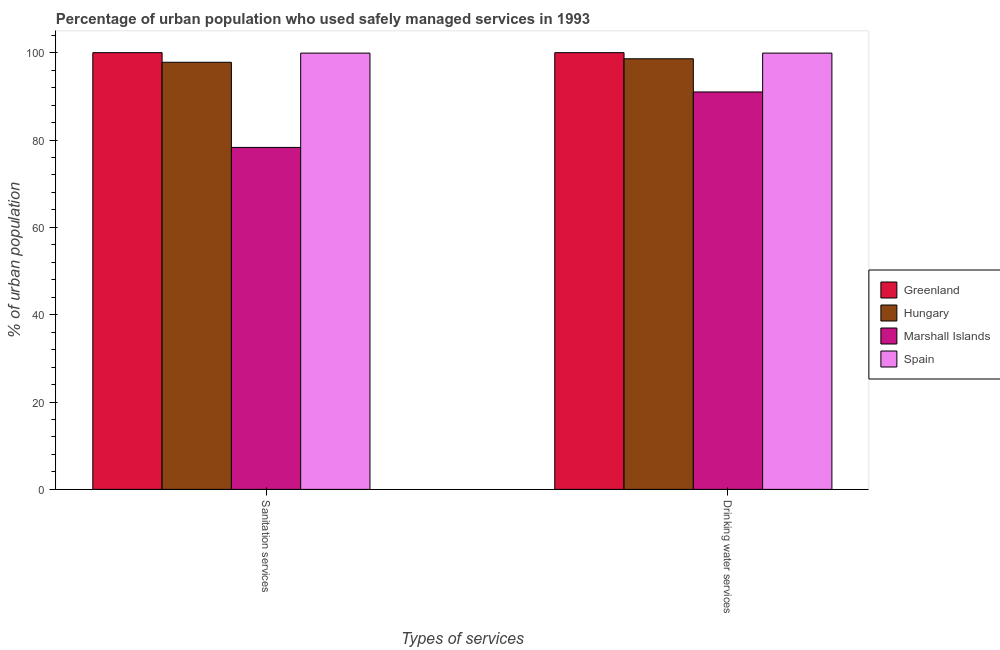How many different coloured bars are there?
Your response must be concise. 4. How many bars are there on the 1st tick from the left?
Your answer should be compact. 4. How many bars are there on the 2nd tick from the right?
Make the answer very short. 4. What is the label of the 1st group of bars from the left?
Keep it short and to the point. Sanitation services. What is the percentage of urban population who used drinking water services in Marshall Islands?
Your response must be concise. 91. Across all countries, what is the maximum percentage of urban population who used drinking water services?
Keep it short and to the point. 100. Across all countries, what is the minimum percentage of urban population who used sanitation services?
Keep it short and to the point. 78.3. In which country was the percentage of urban population who used sanitation services maximum?
Make the answer very short. Greenland. In which country was the percentage of urban population who used sanitation services minimum?
Offer a terse response. Marshall Islands. What is the total percentage of urban population who used sanitation services in the graph?
Your answer should be compact. 376. What is the difference between the percentage of urban population who used drinking water services in Hungary and that in Marshall Islands?
Make the answer very short. 7.6. What is the difference between the percentage of urban population who used drinking water services in Spain and the percentage of urban population who used sanitation services in Greenland?
Ensure brevity in your answer.  -0.1. What is the average percentage of urban population who used sanitation services per country?
Give a very brief answer. 94. What is the ratio of the percentage of urban population who used drinking water services in Marshall Islands to that in Spain?
Your response must be concise. 0.91. Is the percentage of urban population who used sanitation services in Hungary less than that in Spain?
Offer a terse response. Yes. In how many countries, is the percentage of urban population who used drinking water services greater than the average percentage of urban population who used drinking water services taken over all countries?
Keep it short and to the point. 3. What does the 3rd bar from the left in Drinking water services represents?
Offer a terse response. Marshall Islands. Are all the bars in the graph horizontal?
Keep it short and to the point. No. What is the difference between two consecutive major ticks on the Y-axis?
Make the answer very short. 20. Where does the legend appear in the graph?
Make the answer very short. Center right. How many legend labels are there?
Your answer should be compact. 4. What is the title of the graph?
Your answer should be compact. Percentage of urban population who used safely managed services in 1993. What is the label or title of the X-axis?
Provide a succinct answer. Types of services. What is the label or title of the Y-axis?
Your answer should be very brief. % of urban population. What is the % of urban population in Greenland in Sanitation services?
Keep it short and to the point. 100. What is the % of urban population in Hungary in Sanitation services?
Make the answer very short. 97.8. What is the % of urban population of Marshall Islands in Sanitation services?
Offer a very short reply. 78.3. What is the % of urban population of Spain in Sanitation services?
Provide a short and direct response. 99.9. What is the % of urban population of Greenland in Drinking water services?
Make the answer very short. 100. What is the % of urban population of Hungary in Drinking water services?
Offer a terse response. 98.6. What is the % of urban population of Marshall Islands in Drinking water services?
Your response must be concise. 91. What is the % of urban population of Spain in Drinking water services?
Offer a terse response. 99.9. Across all Types of services, what is the maximum % of urban population of Hungary?
Offer a very short reply. 98.6. Across all Types of services, what is the maximum % of urban population in Marshall Islands?
Your response must be concise. 91. Across all Types of services, what is the maximum % of urban population in Spain?
Your response must be concise. 99.9. Across all Types of services, what is the minimum % of urban population of Greenland?
Provide a short and direct response. 100. Across all Types of services, what is the minimum % of urban population in Hungary?
Provide a short and direct response. 97.8. Across all Types of services, what is the minimum % of urban population of Marshall Islands?
Provide a short and direct response. 78.3. Across all Types of services, what is the minimum % of urban population of Spain?
Make the answer very short. 99.9. What is the total % of urban population in Hungary in the graph?
Offer a terse response. 196.4. What is the total % of urban population in Marshall Islands in the graph?
Offer a very short reply. 169.3. What is the total % of urban population of Spain in the graph?
Make the answer very short. 199.8. What is the difference between the % of urban population of Greenland in Sanitation services and that in Drinking water services?
Your answer should be compact. 0. What is the difference between the % of urban population in Hungary in Sanitation services and that in Drinking water services?
Provide a short and direct response. -0.8. What is the difference between the % of urban population of Marshall Islands in Sanitation services and that in Drinking water services?
Provide a succinct answer. -12.7. What is the difference between the % of urban population of Spain in Sanitation services and that in Drinking water services?
Keep it short and to the point. 0. What is the difference between the % of urban population in Greenland in Sanitation services and the % of urban population in Marshall Islands in Drinking water services?
Make the answer very short. 9. What is the difference between the % of urban population of Marshall Islands in Sanitation services and the % of urban population of Spain in Drinking water services?
Make the answer very short. -21.6. What is the average % of urban population of Hungary per Types of services?
Your answer should be very brief. 98.2. What is the average % of urban population of Marshall Islands per Types of services?
Provide a short and direct response. 84.65. What is the average % of urban population in Spain per Types of services?
Your answer should be very brief. 99.9. What is the difference between the % of urban population in Greenland and % of urban population in Hungary in Sanitation services?
Your response must be concise. 2.2. What is the difference between the % of urban population in Greenland and % of urban population in Marshall Islands in Sanitation services?
Offer a very short reply. 21.7. What is the difference between the % of urban population in Marshall Islands and % of urban population in Spain in Sanitation services?
Ensure brevity in your answer.  -21.6. What is the difference between the % of urban population in Greenland and % of urban population in Hungary in Drinking water services?
Your answer should be very brief. 1.4. What is the difference between the % of urban population of Greenland and % of urban population of Marshall Islands in Drinking water services?
Give a very brief answer. 9. What is the difference between the % of urban population in Greenland and % of urban population in Spain in Drinking water services?
Keep it short and to the point. 0.1. What is the difference between the % of urban population of Hungary and % of urban population of Marshall Islands in Drinking water services?
Your response must be concise. 7.6. What is the difference between the % of urban population of Hungary and % of urban population of Spain in Drinking water services?
Offer a very short reply. -1.3. What is the difference between the % of urban population of Marshall Islands and % of urban population of Spain in Drinking water services?
Keep it short and to the point. -8.9. What is the ratio of the % of urban population of Marshall Islands in Sanitation services to that in Drinking water services?
Offer a very short reply. 0.86. What is the ratio of the % of urban population of Spain in Sanitation services to that in Drinking water services?
Make the answer very short. 1. What is the difference between the highest and the second highest % of urban population in Spain?
Make the answer very short. 0. What is the difference between the highest and the lowest % of urban population in Greenland?
Your answer should be very brief. 0. 